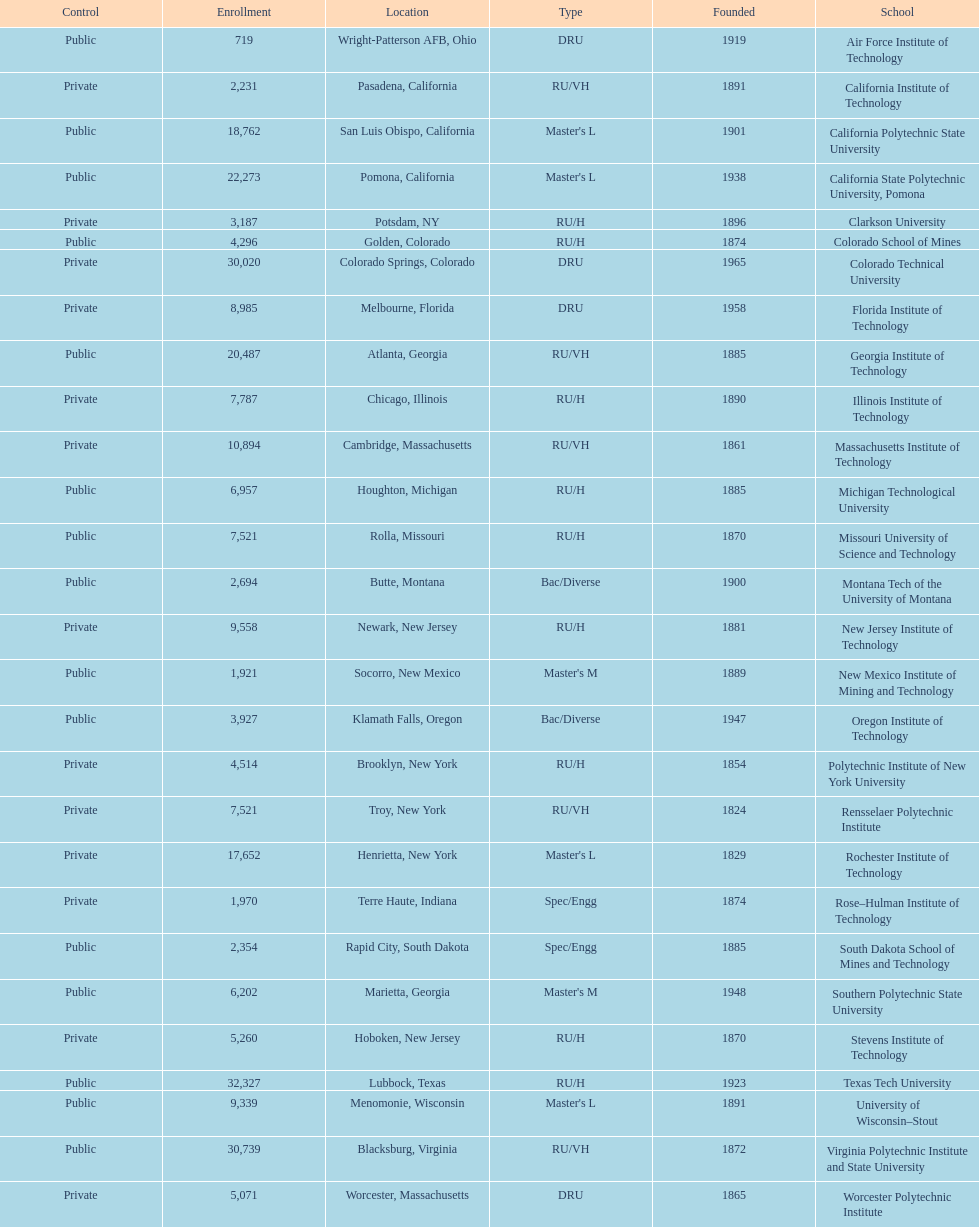Help me parse the entirety of this table. {'header': ['Control', 'Enrollment', 'Location', 'Type', 'Founded', 'School'], 'rows': [['Public', '719', 'Wright-Patterson AFB, Ohio', 'DRU', '1919', 'Air Force Institute of Technology'], ['Private', '2,231', 'Pasadena, California', 'RU/VH', '1891', 'California Institute of Technology'], ['Public', '18,762', 'San Luis Obispo, California', "Master's L", '1901', 'California Polytechnic State University'], ['Public', '22,273', 'Pomona, California', "Master's L", '1938', 'California State Polytechnic University, Pomona'], ['Private', '3,187', 'Potsdam, NY', 'RU/H', '1896', 'Clarkson University'], ['Public', '4,296', 'Golden, Colorado', 'RU/H', '1874', 'Colorado School of Mines'], ['Private', '30,020', 'Colorado Springs, Colorado', 'DRU', '1965', 'Colorado Technical University'], ['Private', '8,985', 'Melbourne, Florida', 'DRU', '1958', 'Florida Institute of Technology'], ['Public', '20,487', 'Atlanta, Georgia', 'RU/VH', '1885', 'Georgia Institute of Technology'], ['Private', '7,787', 'Chicago, Illinois', 'RU/H', '1890', 'Illinois Institute of Technology'], ['Private', '10,894', 'Cambridge, Massachusetts', 'RU/VH', '1861', 'Massachusetts Institute of Technology'], ['Public', '6,957', 'Houghton, Michigan', 'RU/H', '1885', 'Michigan Technological University'], ['Public', '7,521', 'Rolla, Missouri', 'RU/H', '1870', 'Missouri University of Science and Technology'], ['Public', '2,694', 'Butte, Montana', 'Bac/Diverse', '1900', 'Montana Tech of the University of Montana'], ['Private', '9,558', 'Newark, New Jersey', 'RU/H', '1881', 'New Jersey Institute of Technology'], ['Public', '1,921', 'Socorro, New Mexico', "Master's M", '1889', 'New Mexico Institute of Mining and Technology'], ['Public', '3,927', 'Klamath Falls, Oregon', 'Bac/Diverse', '1947', 'Oregon Institute of Technology'], ['Private', '4,514', 'Brooklyn, New York', 'RU/H', '1854', 'Polytechnic Institute of New York University'], ['Private', '7,521', 'Troy, New York', 'RU/VH', '1824', 'Rensselaer Polytechnic Institute'], ['Private', '17,652', 'Henrietta, New York', "Master's L", '1829', 'Rochester Institute of Technology'], ['Private', '1,970', 'Terre Haute, Indiana', 'Spec/Engg', '1874', 'Rose–Hulman Institute of Technology'], ['Public', '2,354', 'Rapid City, South Dakota', 'Spec/Engg', '1885', 'South Dakota School of Mines and Technology'], ['Public', '6,202', 'Marietta, Georgia', "Master's M", '1948', 'Southern Polytechnic State University'], ['Private', '5,260', 'Hoboken, New Jersey', 'RU/H', '1870', 'Stevens Institute of Technology'], ['Public', '32,327', 'Lubbock, Texas', 'RU/H', '1923', 'Texas Tech University'], ['Public', '9,339', 'Menomonie, Wisconsin', "Master's L", '1891', 'University of Wisconsin–Stout'], ['Public', '30,739', 'Blacksburg, Virginia', 'RU/VH', '1872', 'Virginia Polytechnic Institute and State University'], ['Private', '5,071', 'Worcester, Massachusetts', 'DRU', '1865', 'Worcester Polytechnic Institute']]} What is the number of us technological schools in the state of california? 3. 